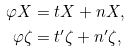<formula> <loc_0><loc_0><loc_500><loc_500>\varphi X & = t X + n X , \\ \varphi \zeta & = t ^ { \prime } \zeta + n ^ { \prime } \zeta ,</formula> 